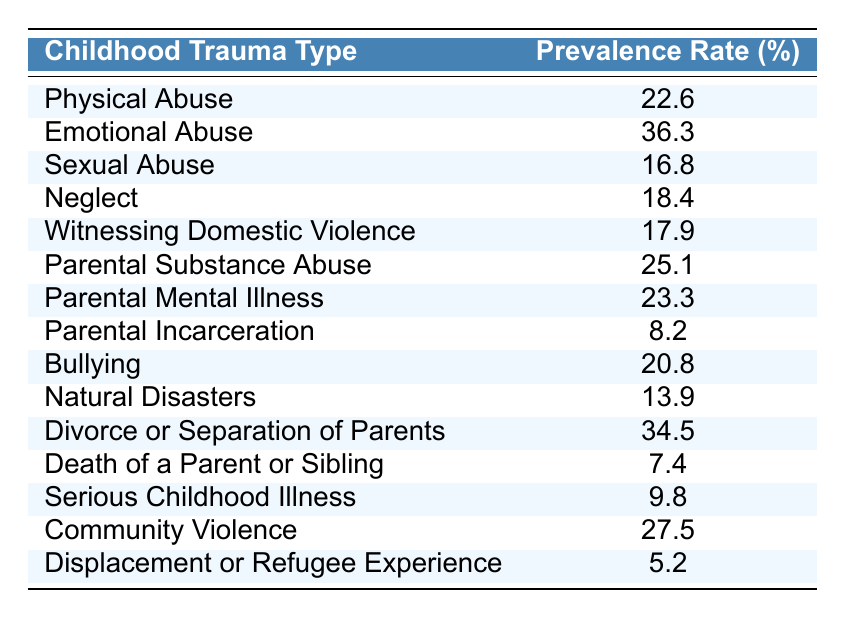What is the prevalence rate of emotional abuse? The table shows the prevalence rate for each type of childhood trauma. For emotional abuse, the rate is explicitly listed as 36.3%.
Answer: 36.3% Which type of childhood trauma has the highest prevalence rate? By scanning the prevalence rates in the table, emotional abuse has the highest rate at 36.3%.
Answer: Emotional Abuse What is the combined prevalence rate of physical abuse and neglect? To find the combined prevalence rate, add the individual rates: physical abuse (22.6%) + neglect (18.4%) = 41.0%.
Answer: 41.0% Is the prevalence rate of parental incarceration higher than that of serious childhood illness? The prevalence rate for parental incarceration is 8.2%, while serious childhood illness is 9.8%. Since 8.2% is less than 9.8%, the answer is no.
Answer: No What is the prevalence rate of witnessing domestic violence compared to bullying? Witnessing domestic violence has a prevalence of 17.9%, while bullying has a rate of 20.8%. Since 17.9% is less than 20.8%, bullying has a higher prevalence.
Answer: Bullying has a higher prevalence rate What is the average prevalence rate across the types of trauma listed? To calculate the average, first sum up all the prevalence rates: (22.6 + 36.3 + 16.8 + 18.4 + 17.9 + 25.1 + 23.3 + 8.2 + 20.8 + 13.9 + 34.5 + 7.4 + 9.8 + 27.5 + 5.2) =  338.6%. There are 15 types of trauma, so the average is 338.6% / 15 ≈ 22.6%.
Answer: 22.6% What percentage of children experience parental substance abuse compared to witnessing domestic violence? Parental substance abuse has a prevalence rate of 25.1%, while witnessing domestic violence has 17.9%. Since 25.1% is greater, parental substance abuse affects a higher percentage of children.
Answer: Parental substance abuse is higher Which trauma type has the lowest prevalence rate? By reviewing the data, displacement or refugee experience shows the lowest prevalence rate at 5.2%.
Answer: Displacement or Refugee Experience If a child is affected by both bullying and parental mental illness, what is their combined trauma prevalence? First, find the rates: bullying is 20.8%, and parental mental illness is 23.3%. When added together: 20.8% + 23.3% = 44.1%.
Answer: 44.1% Are there more trauma types with prevalence rates over 20% or under 20%? Count the rates: Over 20%: Physical Abuse, Emotional Abuse, Parental Substance Abuse, Parental Mental Illness, Community Violence, and Bullying (6 types). Under 20%: Sexual Abuse, Neglect, Witnessing Domestic Violence, Natural Disasters, Divorce/Separation, Death, Serious Childhood Illness, and Displacement (9 types). Thus, there are more under 20%.
Answer: Under 20% has more types 